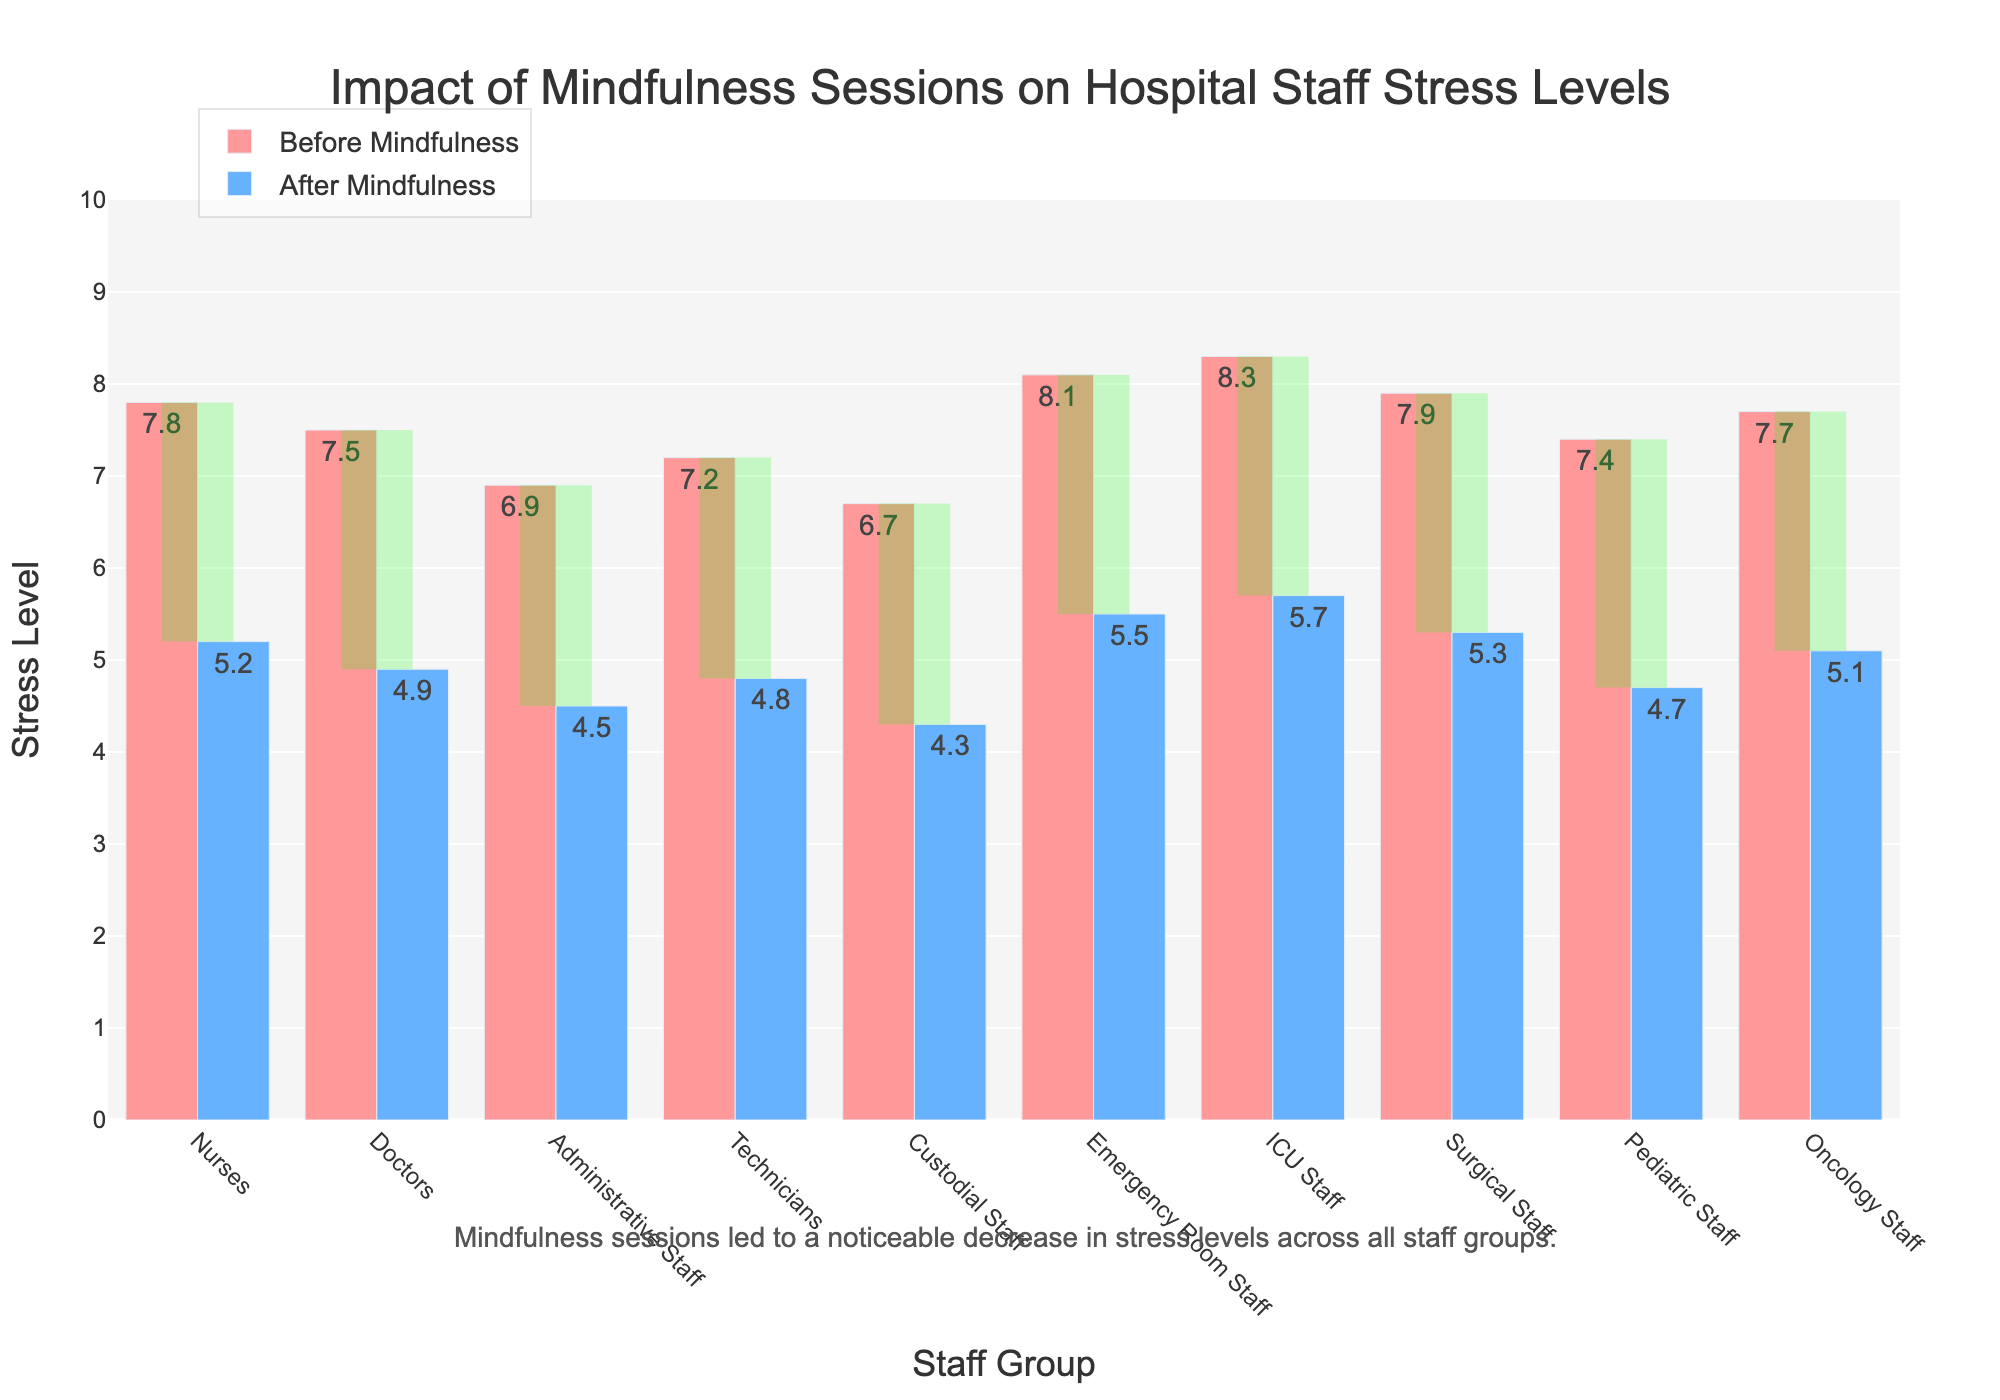What's the average stress level for ICU Staff before and after mindfulness sessions? To find the average stress level for ICU Staff before and after mindfulness sessions, add the 'Before Mindfulness' and 'After Mindfulness' values together, then divide by 2. (8.3 + 5.7)/2 = 7.0
Answer: 7.0 Which staff group reported the highest stress level before mindfulness sessions? By scanning the 'Before Mindfulness' bars, we observe that the ICU Staff reported the highest stress level, with a value of 8.3
Answer: ICU Staff How much did the stress level decrease for Nurses after the mindfulness sessions? Subtract the 'After Mindfulness' value from the 'Before Mindfulness' value for Nurses. (7.8 - 5.2) = 2.6
Answer: 2.6 Identify the staff group with the smallest reduction in stress levels. Calculate the difference between 'Before Mindfulness' and 'After Mindfulness' for each group. The Emergency Room Staff group has the smallest reduction: (8.1 - 5.5) = 2.6
Answer: Emergency Room Staff By how much did the average stress levels of all staff groups decrease after the mindfulness sessions? First, sum the stress levels before and after mindfulness for each staff group, then find the differences. Average the differences: (2.6 + 2.6 + 2.4 + 2.4 + 2.4 + 2.6 + 2.6 + 2.6 + 2.7 + 2.6)/10 = 2.56
Answer: 2.56 Which staff groups' stress levels fell below 5.0 after mindfulness sessions? Look at the 'After Mindfulness' bars and identify those below 5.0: Administrative Staff (4.5), Technicians (4.8), Custodial Staff (4.3), Pediatric Staff (4.7)
Answer: Administrative Staff, Technicians, Custodial Staff, Pediatric Staff Did any staff group maintain their rank order in terms of stress levels before and after mindfulness sessions? Compare the rank order of stress levels before and after mindfulness. Both Nurses and ICU Staff maintained their rank order, with Nurses starting at 7.8 and lowering to 5.2, while ICU Staff started at 8.3 and lowered to 5.7
Answer: Nurses, ICU Staff What percentage reduction was observed in the stress level of Oncology Staff after mindfulness sessions? Calculate the percentage reduction: ((7.7 - 5.1) / 7.7) * 100 ≈ 33.77%
Answer: 33.77% 